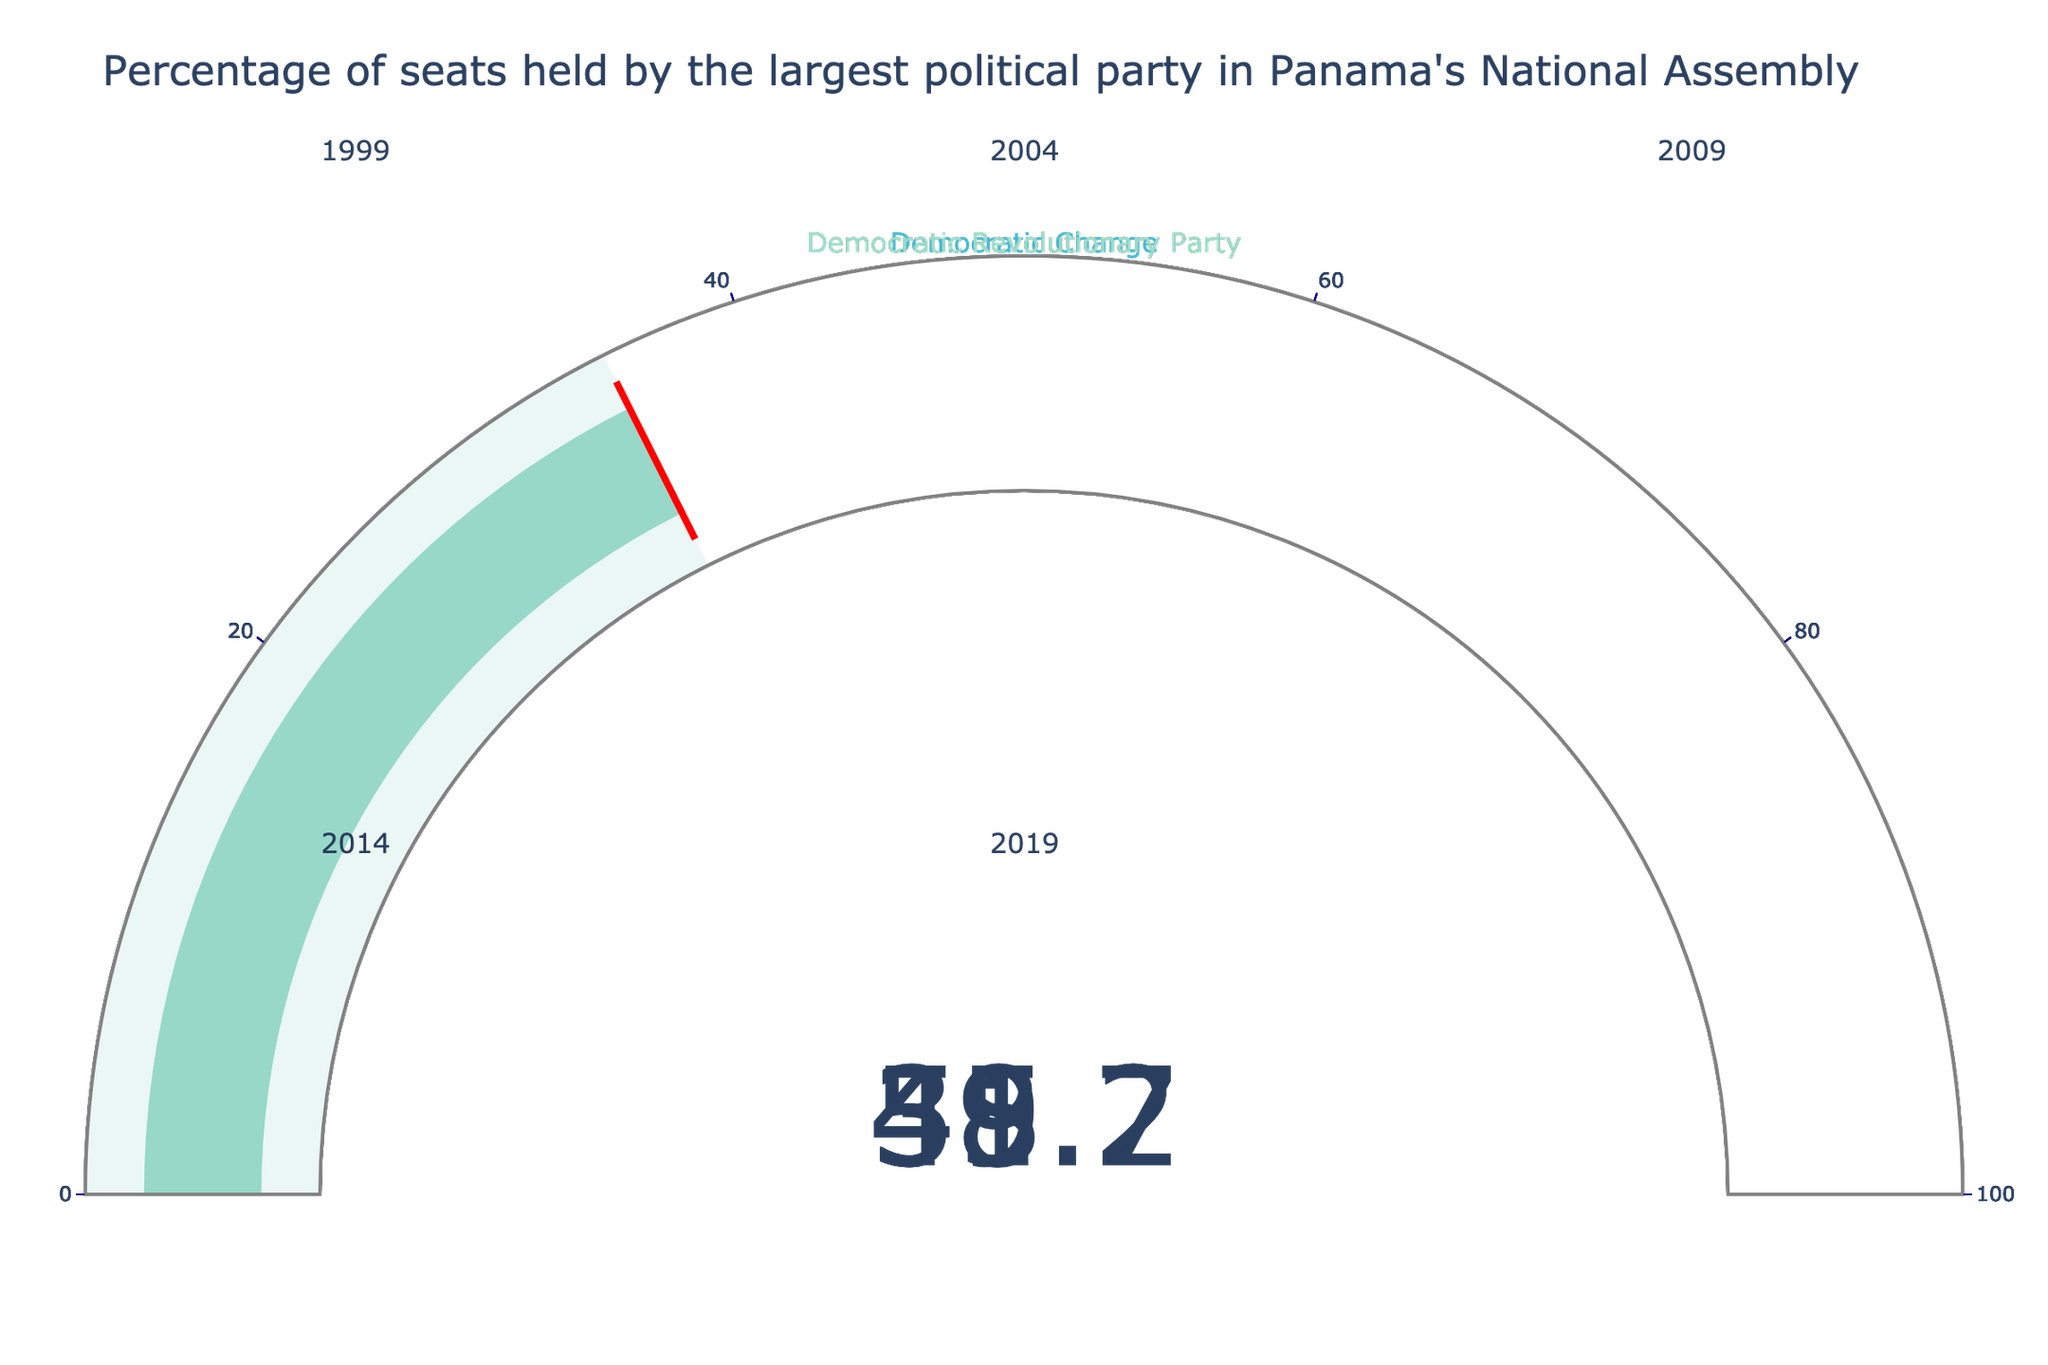What's the percentage of seats held by the Democratic Revolutionary Party in 2004? The Democratic Revolutionary Party's gauge chart for the year 2004 shows a percentage value.
Answer: 41.7 Which year did the Democratic Revolutionary Party have the highest percentage of seats among the listed years? Comparing all the gauge charts for the years 1999, 2004, 2014, and 2019, the highest percentage held by the Democratic Revolutionary Party is visible in 1999.
Answer: 1999 What's the difference in the percentage of seats held by the Democratic Revolutionary Party between 1999 and 2004? The percentage in 1999 is 48.7, and in 2004 it is 41.7. The difference is 48.7 - 41.7.
Answer: 7.0 Which party held the largest percentage of seats in 2009? The gauge chart for 2009 indicates that Democratic Change was the party with the largest percentage.
Answer: Democratic Change Between 1999 and 2019, which year saw the largest drop in the percentage of seats held by the Democratic Revolutionary Party? Calculate the difference in the percentages for each consecutive year: 
1999-2004: 48.7 - 41.7 = 7.0
2004-2009: 41.7 - 35.2 = 6.5 
2009-2014: 59.2 - 35.2 = 24 (here 2009 is skipped as it is not Democratic Revolutionary Party)
2014-2019: 35.2 - 35.2 = 0
The largest drop is from 2009 to 2014 (ignoring non-Democratic Revolutionary Party years), but in continuous Democratic Revolutionary Party years, it’s from 1999 to 2004.
Answer: 2004 What is the average percentage of seats held by the Democratic Revolutionary Party across the years listed? Sum the percentages for the Democratic Revolutionary Party: 48.7 + 41.7 + 35.2 + 35.2. Then divide by the number of years, 4.
Answer: 40.2 In which year did the Democratic Revolutionary Party have an equal percentage of seats? Examine the gauge charts for years with Democratic Revolutionary Party and look for identical percentage values. The percentages for 2014 and 2019 are both 35.2.
Answer: 2014 and 2019 Which party saw the highest percentage of seats in any given year among the years listed? Look at all gauge charts and identify the highest value across all years. Democratic Change had the highest with 59.2 in 2009.
Answer: Democratic Change (2009) How many different parties are represented in the gauge charts? Count the distinct party names across all the gauge charts.
Answer: 2 